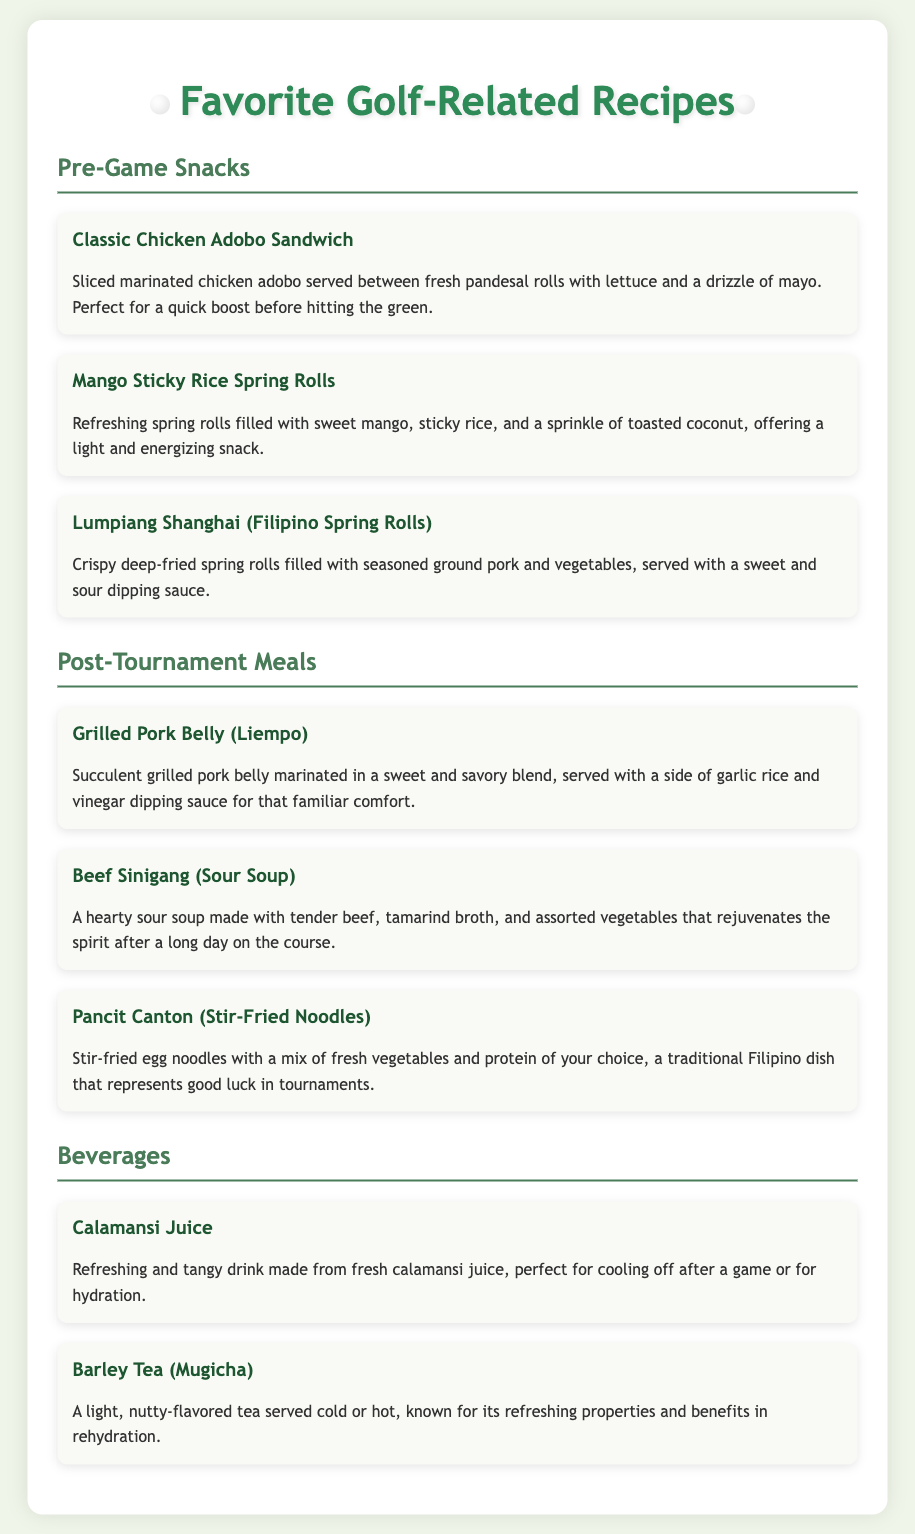what is the first pre-game snack listed? The first pre-game snack is described in the "Pre-Game Snacks" section of the document.
Answer: Classic Chicken Adobo Sandwich how many post-tournament meals are there? The post-tournament meals can be counted in the "Post-Tournament Meals" section, listing three meals.
Answer: 3 what is one ingredient in the Beef Sinigang? The ingredients for the Beef Sinigang are mentioned in its description in the document.
Answer: Tamarind which beverage is known for rehydration? The document includes a beverage that specifically mentions benefits in rehydration.
Answer: Barley Tea (Mugicha) what type of spring rolls are mentioned as a pre-game snack? The type of spring rolls can be found in the "Pre-Game Snacks" section of the document.
Answer: Lumpiang Shanghai what side is served with the Grilled Pork Belly? The side for this dish is mentioned in its description in the document.
Answer: Garlic rice 